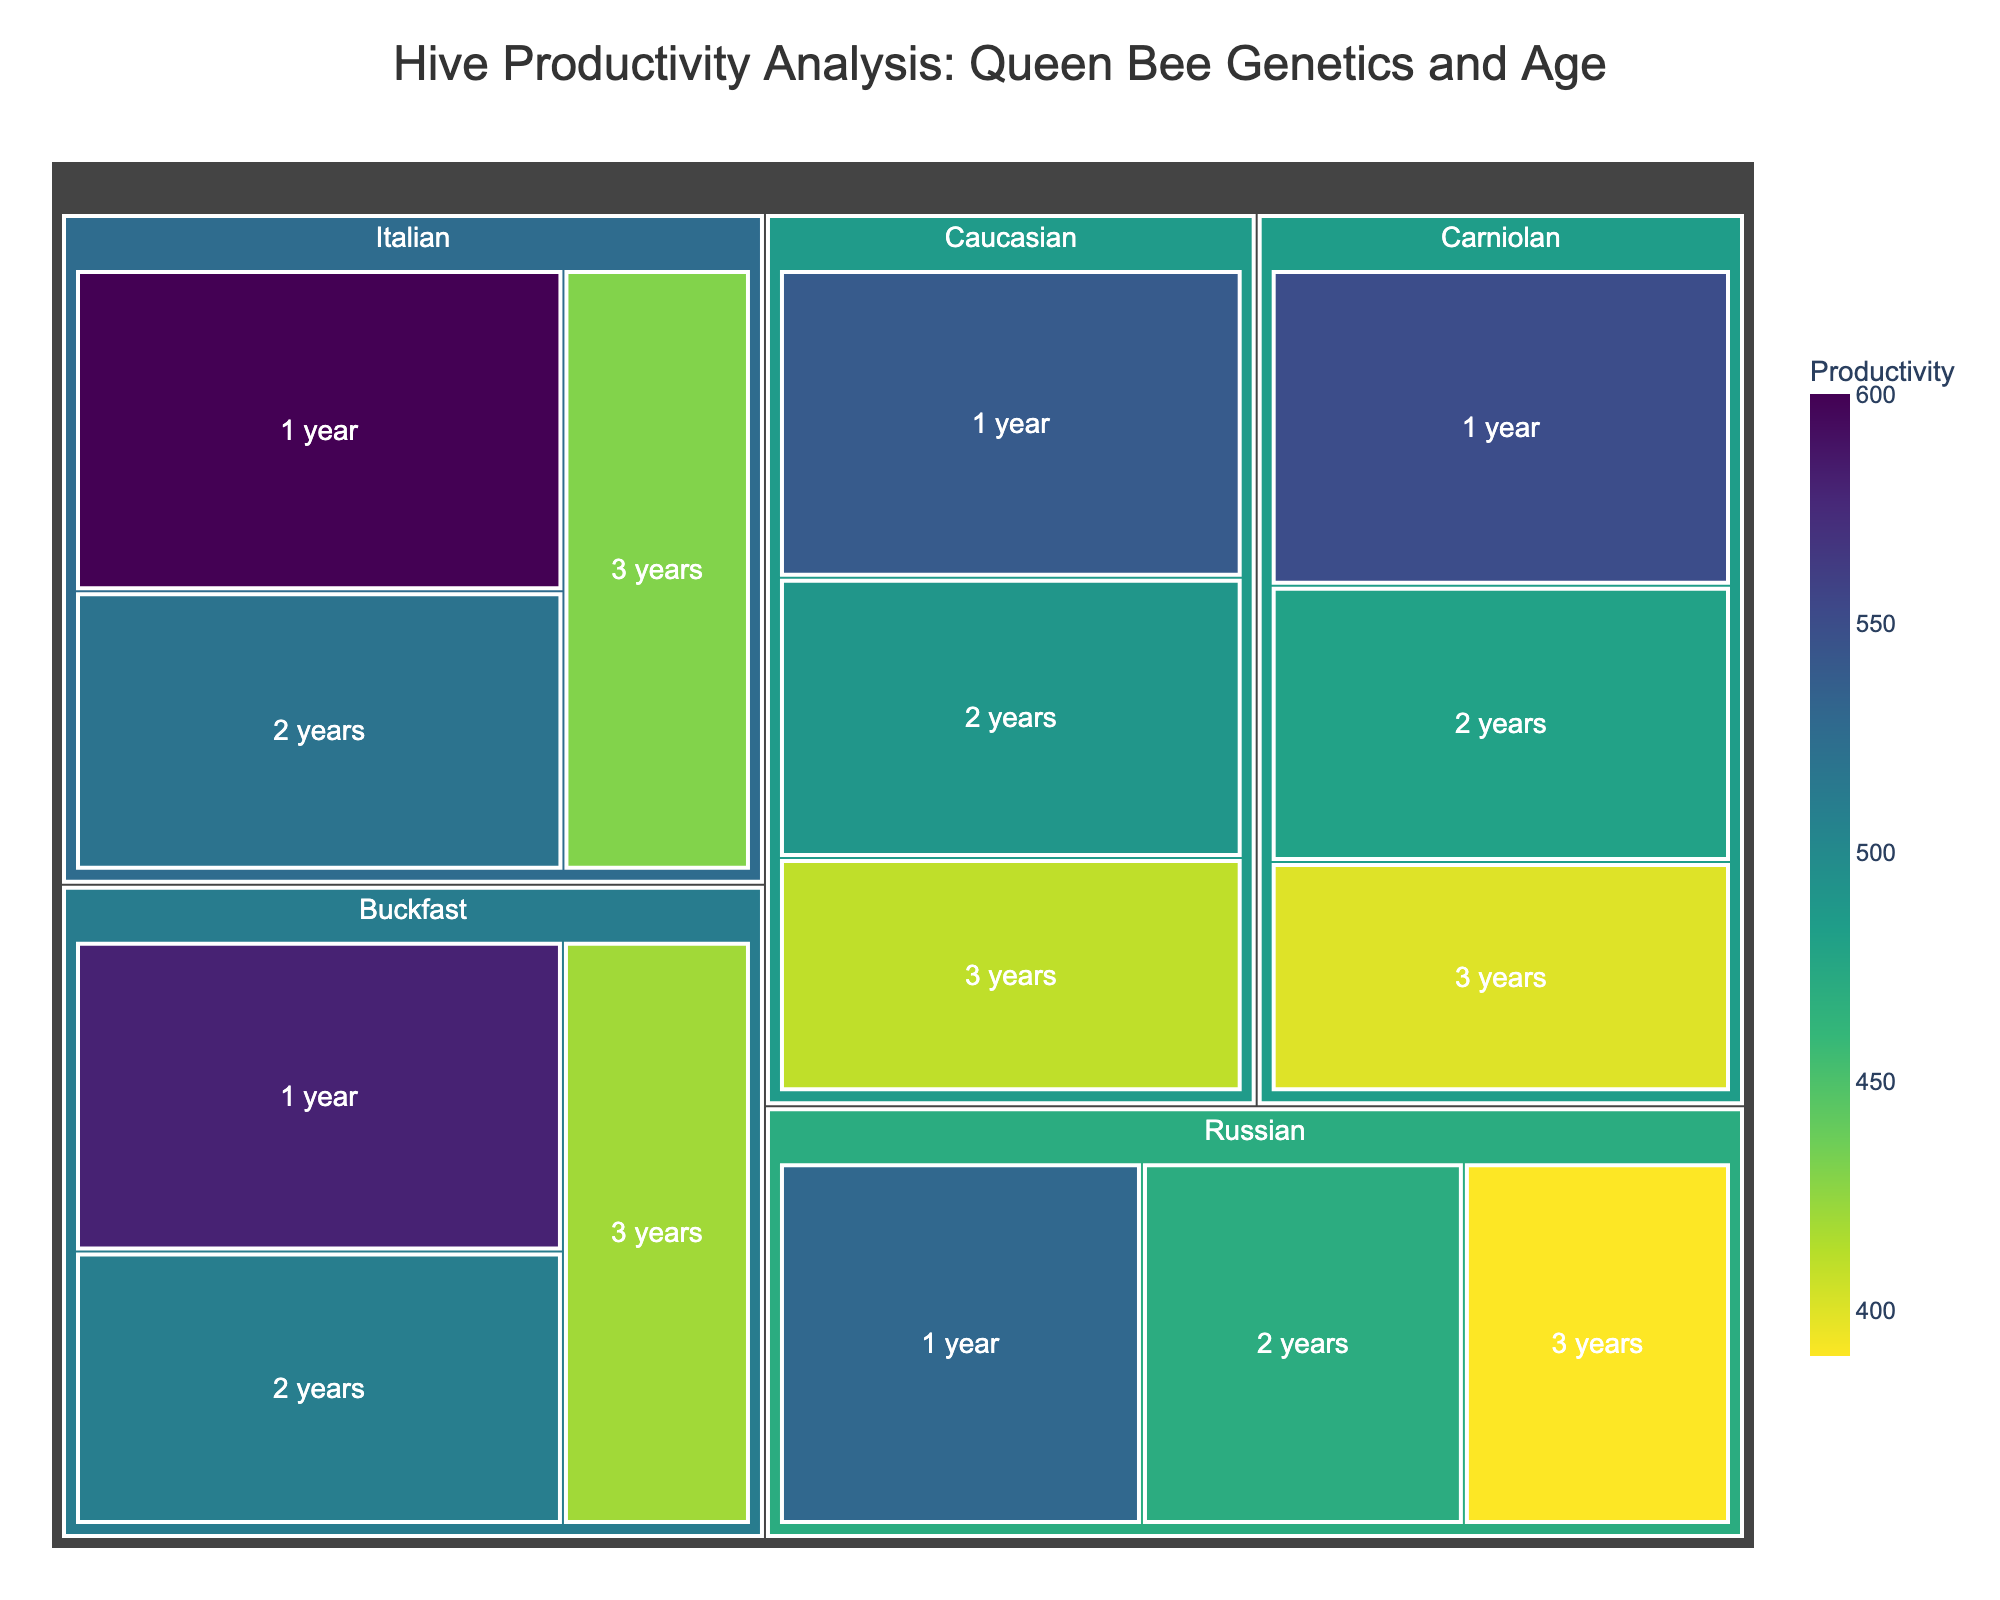What's the title of the figure? The title is prominently displayed at the top of the treemap.
Answer: Hive Productivity Analysis: Queen Bee Genetics and Age How many distinct genetics of queen bees are analyzed in the treemap? By visually counting the top-level categories in the treemap, representing different genetics, we can see there are six, as each genetics category has its distinct color block.
Answer: 6 Which genetics and age category has the highest productivity level? By observing the color gradient and labels, the darkest (most saturated) color corresponds to the highest productivity, which is Italian queen bees at 1 year old with a productivity of 600.
Answer: Italian, 1 year What's the difference in productivity between Carniolan queens of 1 year and 3 years? Carniolan 1-year queens have a productivity of 550, and 3-year queens have 400. The difference is 550 - 400 = 150.
Answer: 150 What's the average productivity of Buckfast queens across all ages? Sum the productivities of all ages for Buckfast (580 + 510 + 420) and divide by the number of ages (3). \( (580 + 510 + 420) / 3 = 1510 / 3 = 503.33 \)
Answer: 503.33 Which age of queen bees generally shows the lowest productivity across all genetics? By examining the treemap, it’s clear that 3-year-old queens generally have lower productivity compared to 1-year and 2-year.
Answer: 3 years Compare the productivity between Russian and Caucasian queen bees at 2 years. Which is higher? Russian 2-year queens have a productivity of 470, while Caucasian 2-year queens have 490. Hence, Caucasian is higher.
Answer: Caucasian Calculate the total productivity for Italian and Buckfast genetics. Italian: \( 600 + 520 + 430 = 1550 \); Buckfast: \( 580 + 510 + 420 = 1510 \); Total: \( 1550 + 1510 = 3060 \)
Answer: 3060 What is the color scheme used to represent productivity levels in the treemap? The colors range from a lighter to darker scale where the darker shade represents higher productivity levels, according to the continuous scale.
Answer: Viridis Which category of queen bees, identified by genetics and age, has the lowest productivity? By looking at the lightest color shade, the lowest productivity corresponds to Russian queen bees at 3 years old, with a productivity of 390.
Answer: Russian, 3 years 